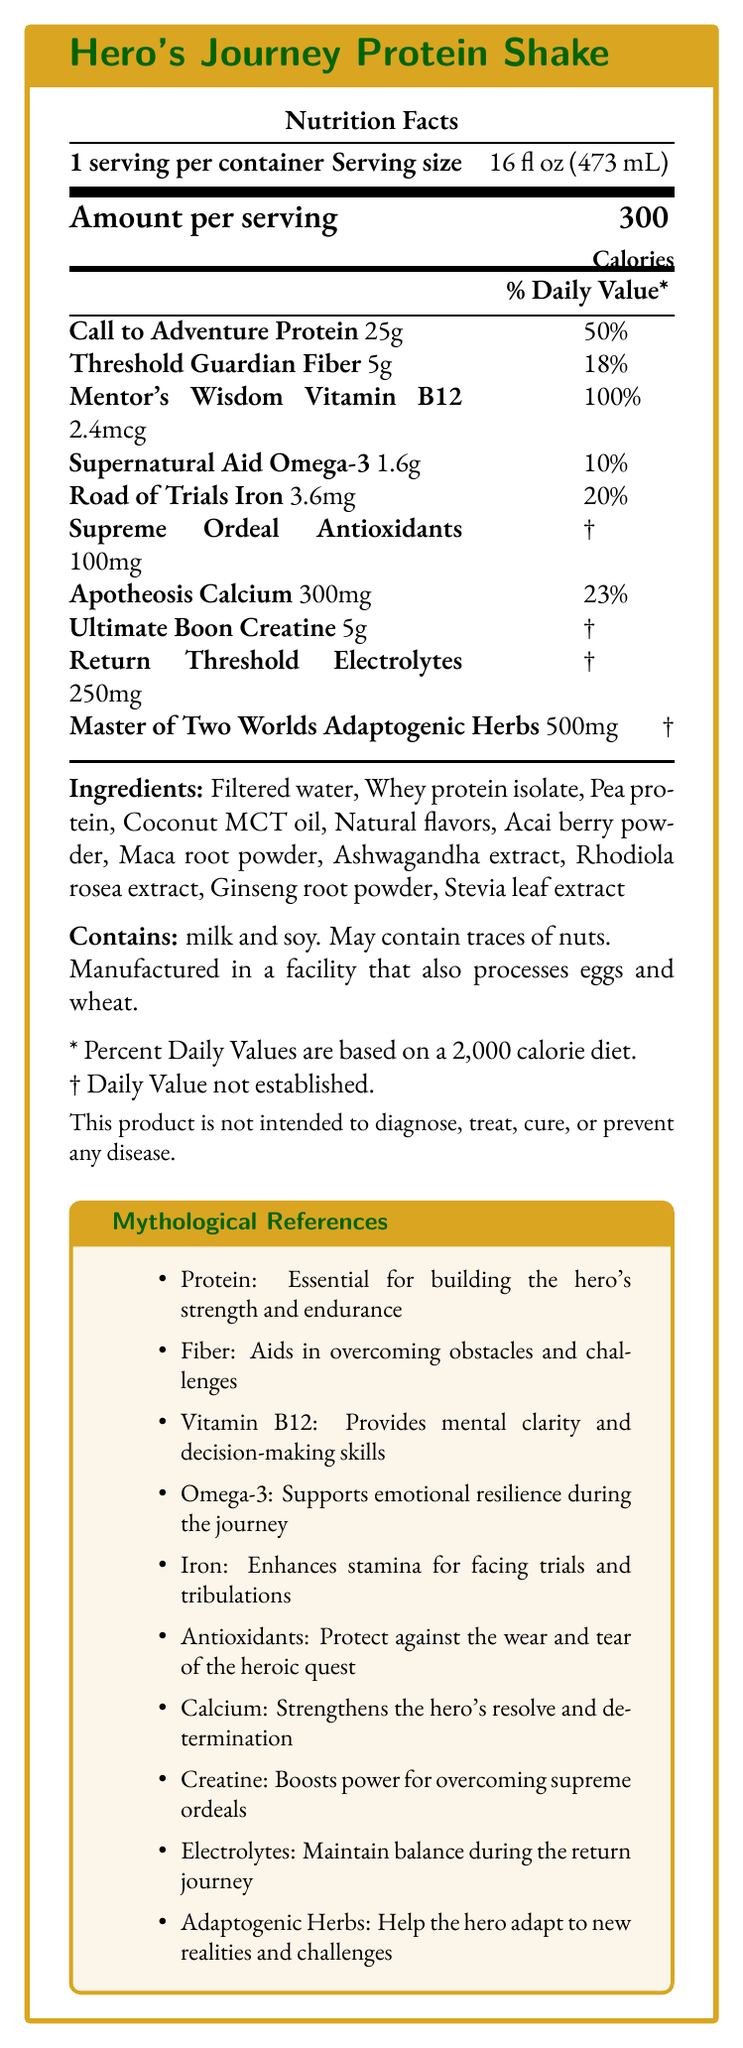what is the serving size of the Hero's Journey Protein Shake? The serving size is listed near the top of the Nutrition Facts section.
Answer: 16 fl oz (473 mL) how many calories are in one serving of the Hero's Journey Protein Shake? The document states the amount per serving is 300 calories.
Answer: 300 what percentage of the daily value is provided by the Call to Adventure Protein? The document lists Call to Adventure Protein as providing 50% of the daily value.
Answer: 50% what allergens are contained in the Hero's Journey Protein Shake? The allergens section specifically lists milk and soy.
Answer: milk and soy how much Iron is included per serving, and what is its daily value percentage? Road of Trials Iron is listed as 3.6 mg and 20% of the daily value.
Answer: 3.6 mg, 20% which nutrient is referred to as "Supernatural Aid"? The document lists Omega-3 as Supernatural Aid in the nutrients section.
Answer: Omega-3 I. Vitamin B12
II. Electrolytes
III. Calcium Mentor's Wisdom corresponds to Vitamin B12, Apotheosis corresponds to Calcium, and Return Threshold corresponds to Electrolytes.
Answer: A. I, B. III, C. II which nutrient has the highest daily value percentage? A. Call to Adventure Protein B. Mentor's Wisdom Vitamin B12 C. Apothosis Calcium D. Threshold Guardian Fiber Mentor's Wisdom Vitamin B12 has the highest daily value percentage at 100%.
Answer: B are there any ingredients used for flavoring in the Hero's Journey Protein Shake? Yes/No The document lists "Natural flavors" among the ingredients.
Answer: Yes summarize the main idea of the document. The document gives comprehensive nutritional details of the protein shake along with mythological references linking nutrients to stages in the hero’s journey. It also covers ingredients and potential allergens.
Answer: The Hero's Journey Protein Shake provides a detailed nutrition facts label including various nutrients, their quantities, and corresponding daily values, all matched with the stages of the hero's journey archetype. The document also lists ingredients, allergens, and disclaimers. what is the exact amount of Creatine in the Hero's Journey Protein Shake and its daily value percentage? The document lists Creatine as 5g with a daily value marked †, meaning not established.
Answer: 5g, † what is the purpose of Omega-3 according to the mythological references provided? The mythological references section states that Omega-3 supports emotional resilience during the journey.
Answer: Supports emotional resilience during the journey How is the nutrient “Road of Trials Iron” beneficial to the hero during their journey? The Road of Trials Iron helps by enhancing stamina as detailed in the mythological references.
Answer: Enhances stamina for facing trials and tribulations what is the approximate daily value of Threshold Guardian Fiber? A. 10% B. 18% C. 23% Threshold Guardian Fiber has a daily value of 18% as listed in the nutrients section.
Answer: B which stage corresponds to Antioxidants, and what is its amount per serving? Antioxidants are associated with the Supreme Ordeal and have a quantity of 100mg per serving.
Answer: Supreme Ordeal, 100mg Is any daily value established for the Ultimate Boon Creatine? The daily value for Ultimate Boon Creatine is marked as †, indicating it is not established.
Answer: No what ingredients in the Hero's Journey Protein Shake might provide adaptogenic effects? These ingredients are listed in the ingredients section and are known for their adaptogenic properties.
Answer: Ashwagandha extract, Rhodiola rosea extract, Ginseng root powder which nutrients do not have a defined daily value percentage? The nutrients listed with † do not have a defined daily value percentage.
Answer: Supreme Ordeal Antioxidants, Ultimate Boon Creatine, Return Threshold Electrolytes, Master of Two Worlds Adaptogenic Herbs Can we determine the amount of Fat in the Hero's Journey Protein Shake from the document? The document does not provide details specific to the amount of fat in the shake.
Answer: Not enough information 